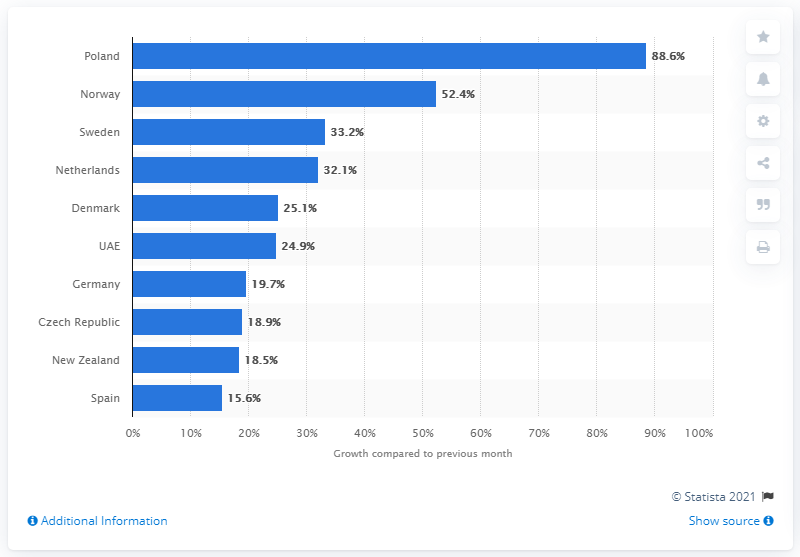List a handful of essential elements in this visual. According to data, downloads of TikTok in Poland increased by 88.6% compared to the previous month. 